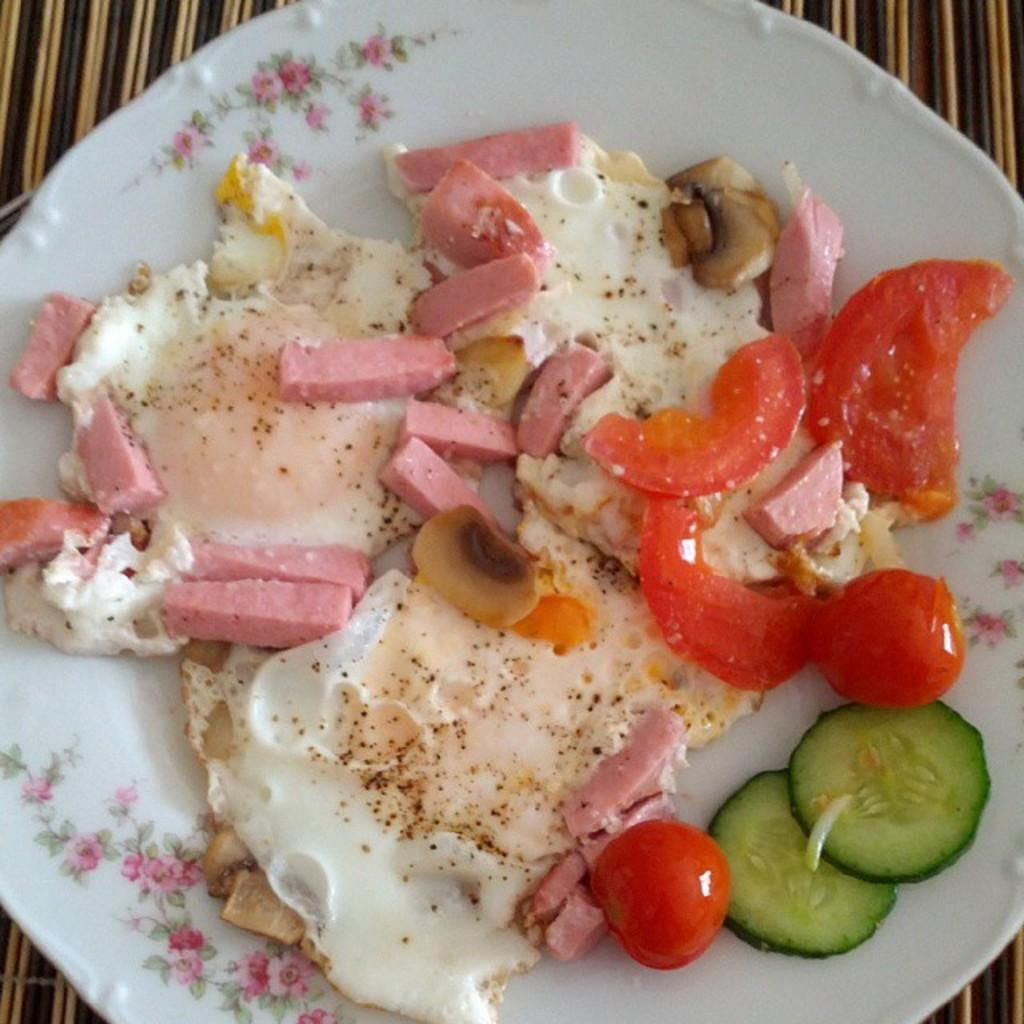What type of food can be seen in the image? There are vegetable pieces and other food items in the image. How are the food items arranged? The food items are arranged on a white color plate. What is the color of the plate? The plate is white. On what surface is the plate placed? The white color plate is placed on another surface. What type of legal advice can be seen in the image? There is no legal advice present in the image; it features food items arranged on a white plate. What type of jam is spread on the soap in the image? There is no jam or soap present in the image; it only contains food items and a white plate. 